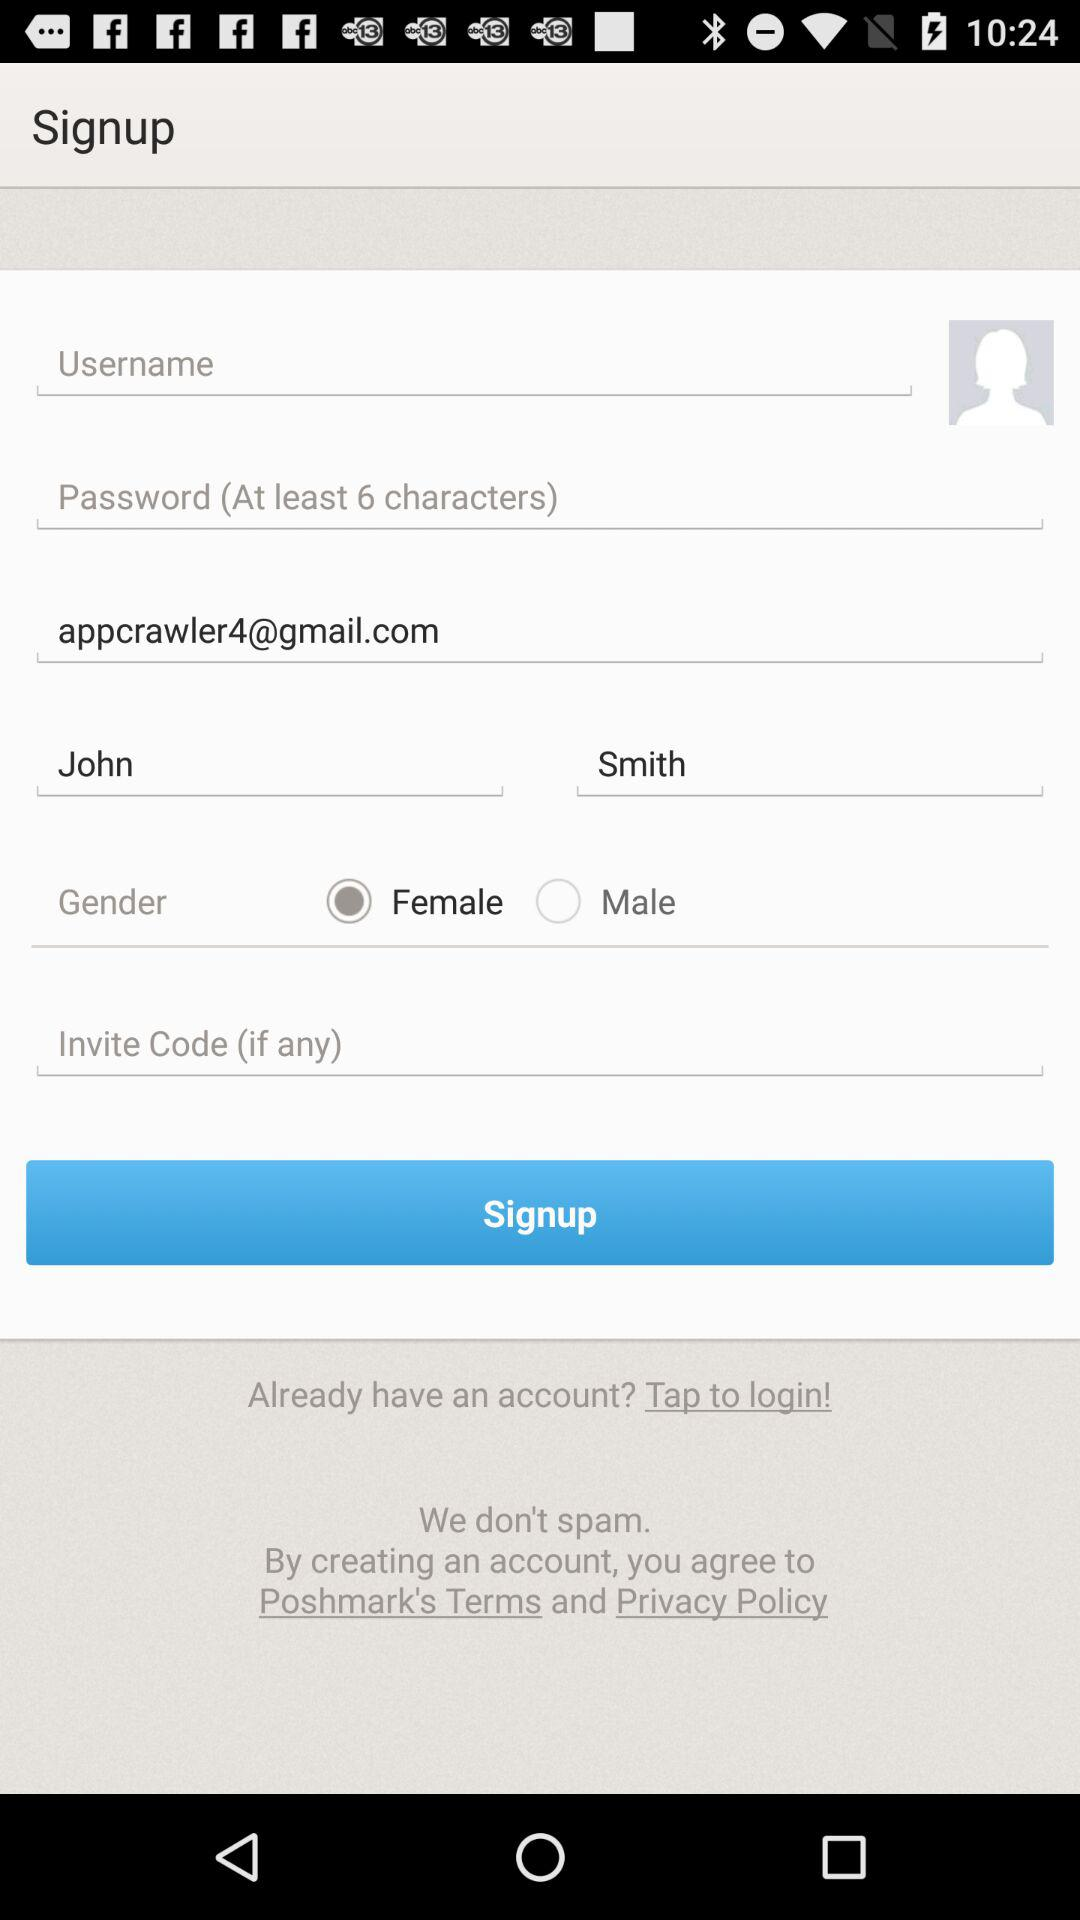What is the user's last name? The user's last name is Smith. 